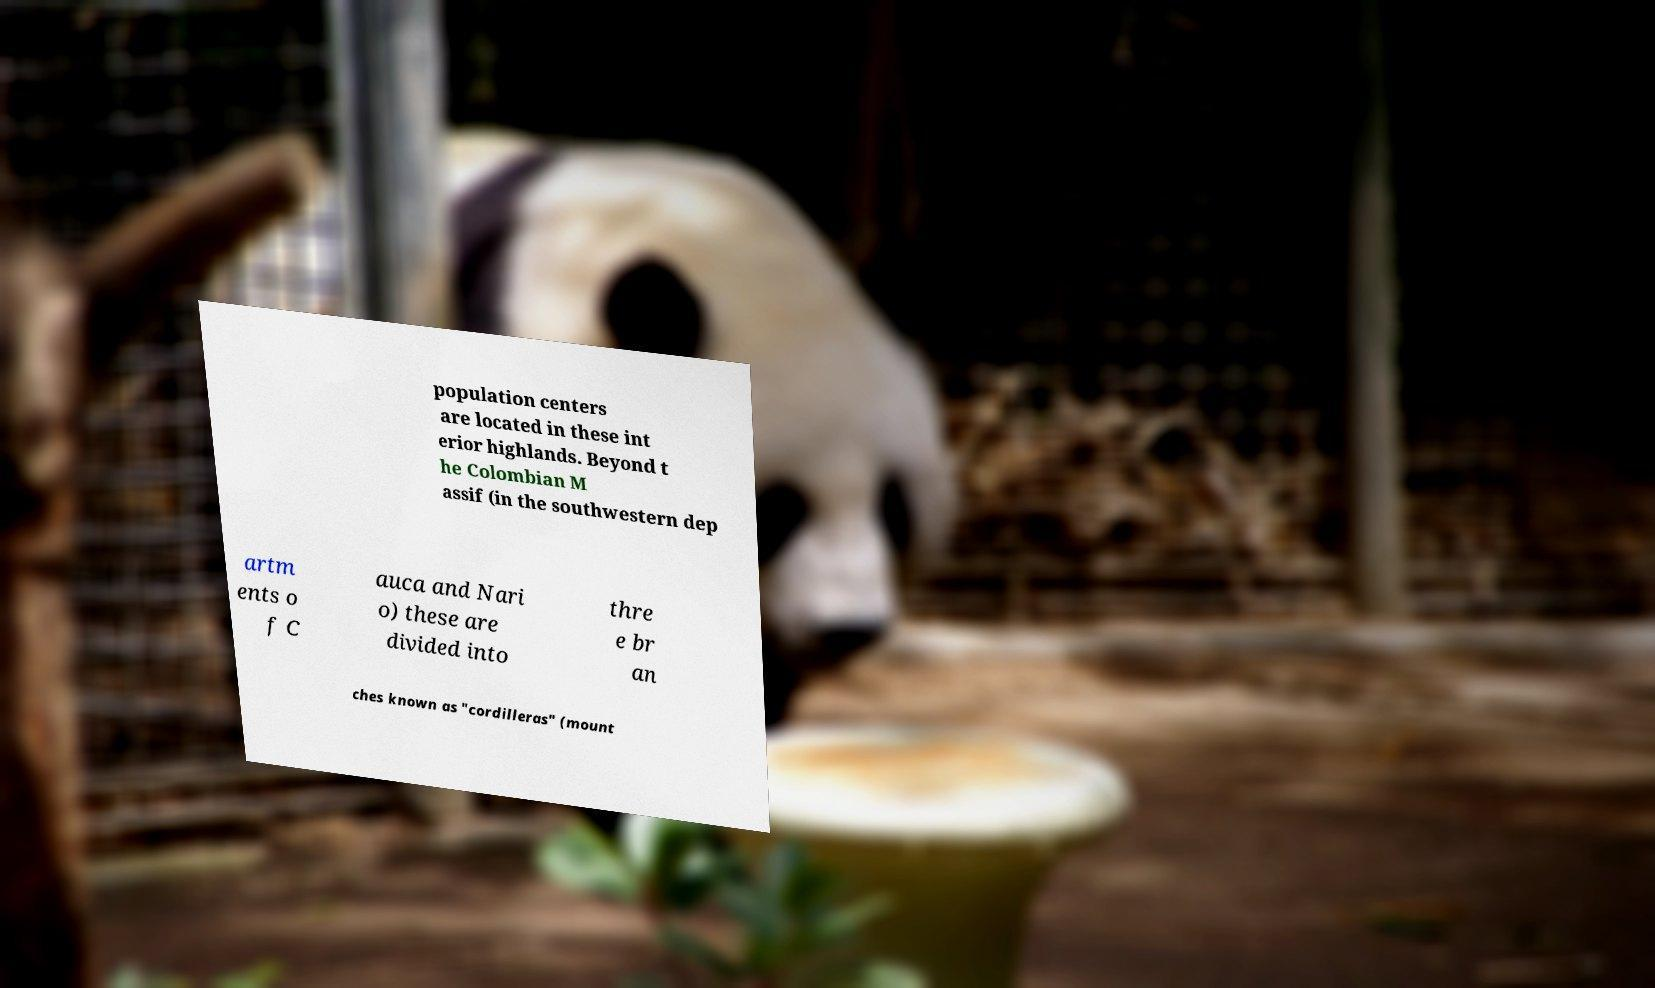Can you read and provide the text displayed in the image?This photo seems to have some interesting text. Can you extract and type it out for me? population centers are located in these int erior highlands. Beyond t he Colombian M assif (in the southwestern dep artm ents o f C auca and Nari o) these are divided into thre e br an ches known as "cordilleras" (mount 